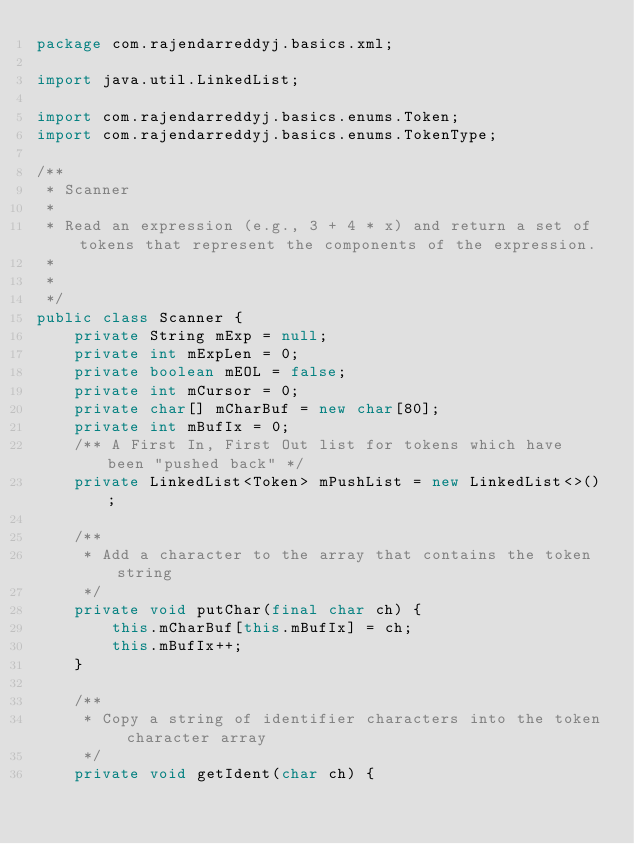<code> <loc_0><loc_0><loc_500><loc_500><_Java_>package com.rajendarreddyj.basics.xml;

import java.util.LinkedList;

import com.rajendarreddyj.basics.enums.Token;
import com.rajendarreddyj.basics.enums.TokenType;

/**
 * Scanner
 *
 * Read an expression (e.g., 3 + 4 * x) and return a set of tokens that represent the components of the expression.
 *
 * 
 */
public class Scanner {
    private String mExp = null;
    private int mExpLen = 0;
    private boolean mEOL = false;
    private int mCursor = 0;
    private char[] mCharBuf = new char[80];
    private int mBufIx = 0;
    /** A First In, First Out list for tokens which have been "pushed back" */
    private LinkedList<Token> mPushList = new LinkedList<>();

    /**
     * Add a character to the array that contains the token string
     */
    private void putChar(final char ch) {
        this.mCharBuf[this.mBufIx] = ch;
        this.mBufIx++;
    }

    /**
     * Copy a string of identifier characters into the token character array
     */
    private void getIdent(char ch) {</code> 